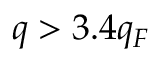<formula> <loc_0><loc_0><loc_500><loc_500>q > 3 . 4 q _ { F }</formula> 